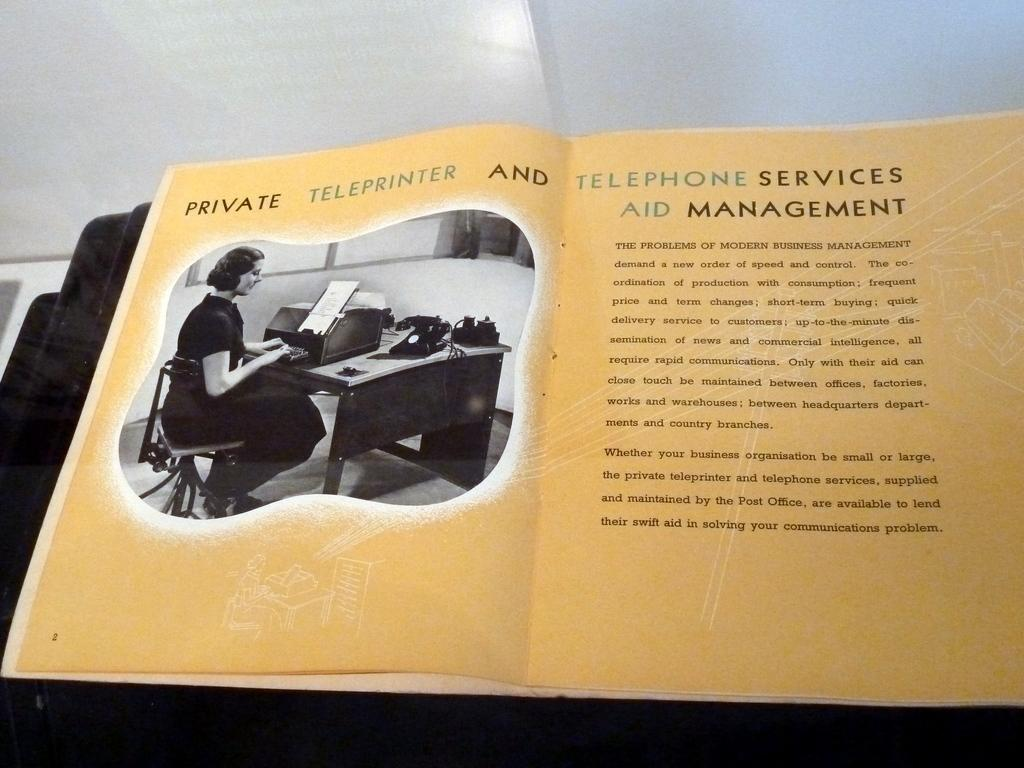<image>
Create a compact narrative representing the image presented. An old ad for a private teleprinter and telephone services aid management company. 